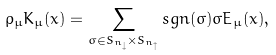<formula> <loc_0><loc_0><loc_500><loc_500>\rho _ { \mu } K _ { \mu } ( x ) = \sum _ { \sigma \in S _ { n _ { \downarrow } } \times S _ { n _ { \uparrow } } } s g n ( \sigma ) \sigma E _ { \mu } ( x ) ,</formula> 